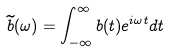Convert formula to latex. <formula><loc_0><loc_0><loc_500><loc_500>\widetilde { b } ( \omega ) = \int _ { - \infty } ^ { \infty } b ( t ) e ^ { i \omega t } d t \,</formula> 